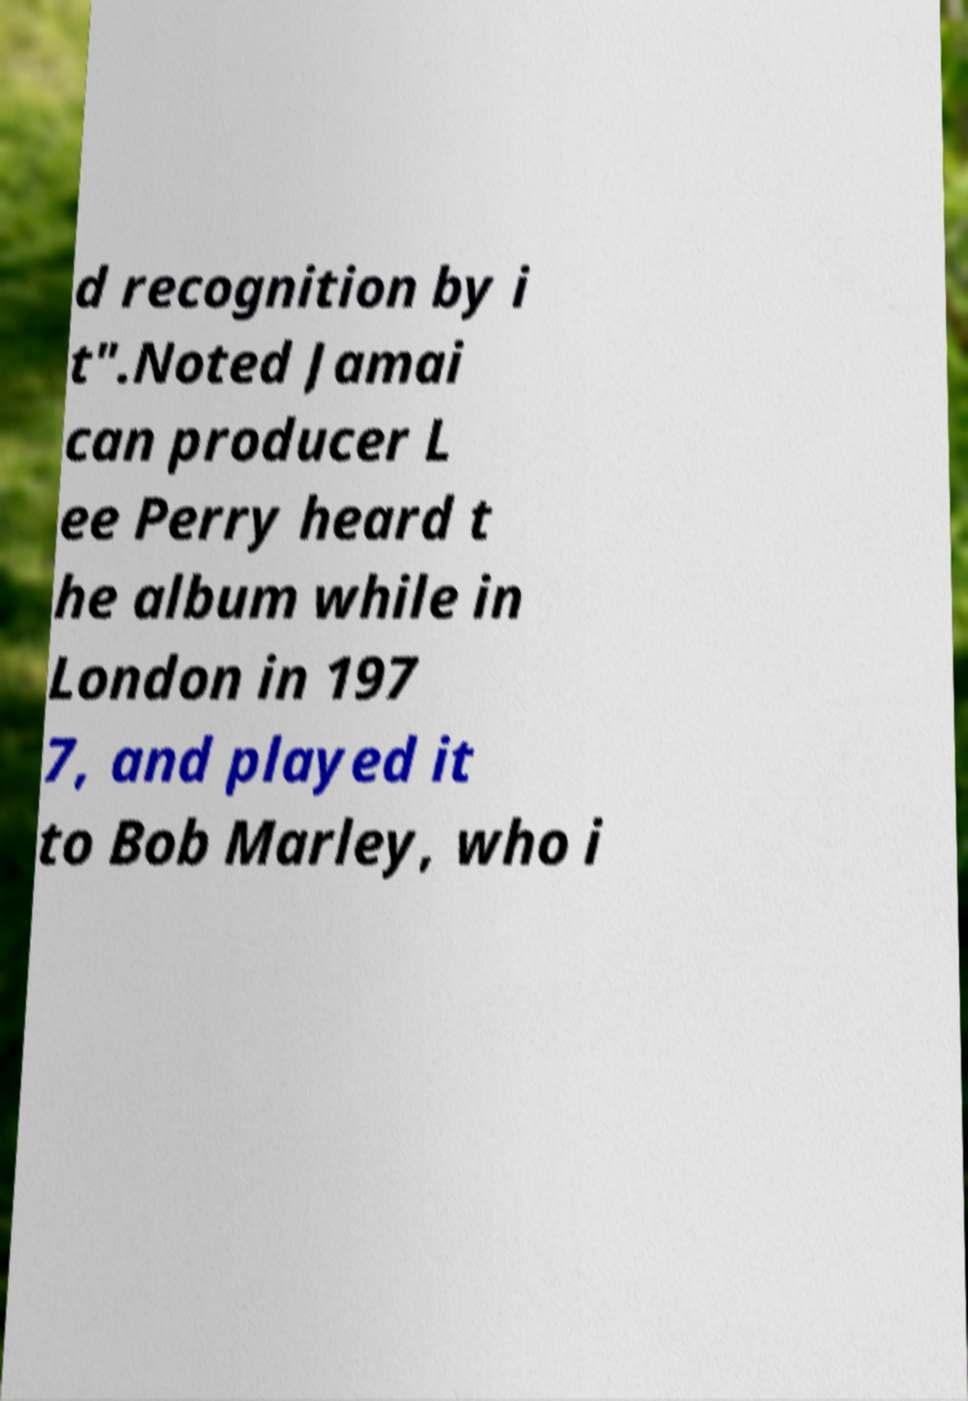I need the written content from this picture converted into text. Can you do that? d recognition by i t".Noted Jamai can producer L ee Perry heard t he album while in London in 197 7, and played it to Bob Marley, who i 